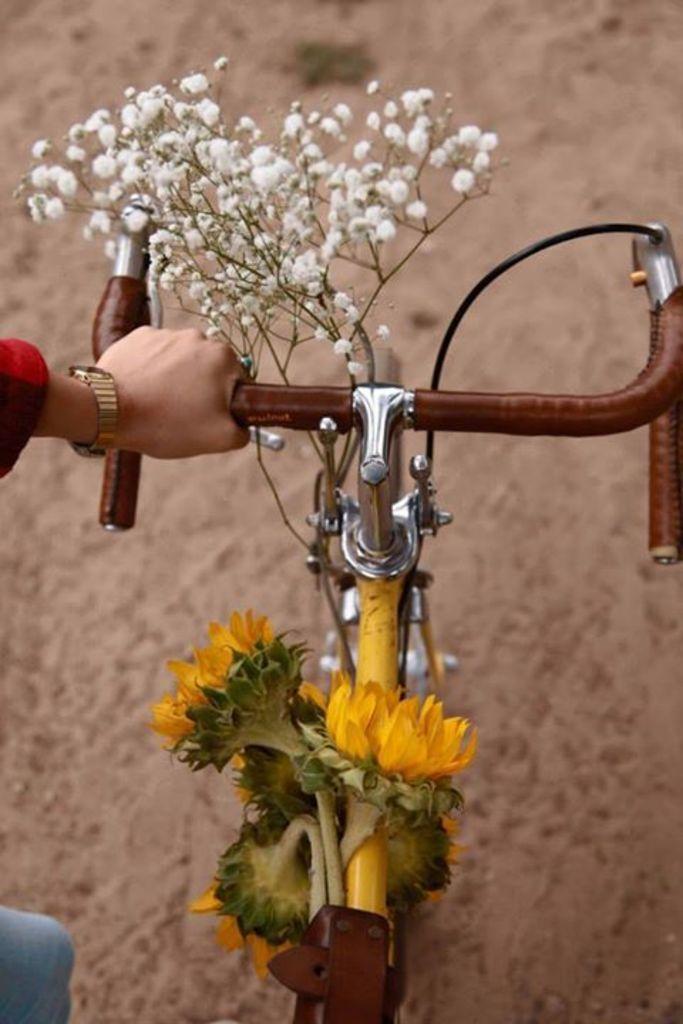In one or two sentences, can you explain what this image depicts? In this image we can see a person holding the handle of a bicycle which is decorated with some flowers. 